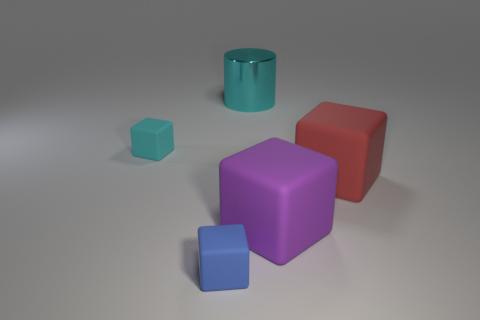How big is the cyan cylinder?
Offer a very short reply. Large. Are there fewer small blue rubber cubes that are on the right side of the big purple block than cyan rubber things?
Make the answer very short. Yes. Does the purple cube have the same material as the cube behind the red matte cube?
Make the answer very short. Yes. There is a cyan object that is right of the rubber block on the left side of the small blue matte thing; is there a rubber block that is to the left of it?
Make the answer very short. Yes. Is there any other thing that has the same size as the cyan rubber thing?
Your response must be concise. Yes. What is the color of the other big cube that is the same material as the big red block?
Offer a very short reply. Purple. What is the size of the rubber object that is to the left of the shiny thing and in front of the small cyan object?
Make the answer very short. Small. Are there fewer blue matte blocks to the right of the big cyan cylinder than red rubber blocks that are in front of the red object?
Offer a terse response. No. Are the small cube on the right side of the small cyan matte cube and the large thing that is behind the red rubber thing made of the same material?
Your answer should be very brief. No. What is the shape of the object that is in front of the large red block and on the right side of the big cyan shiny cylinder?
Your answer should be compact. Cube. 